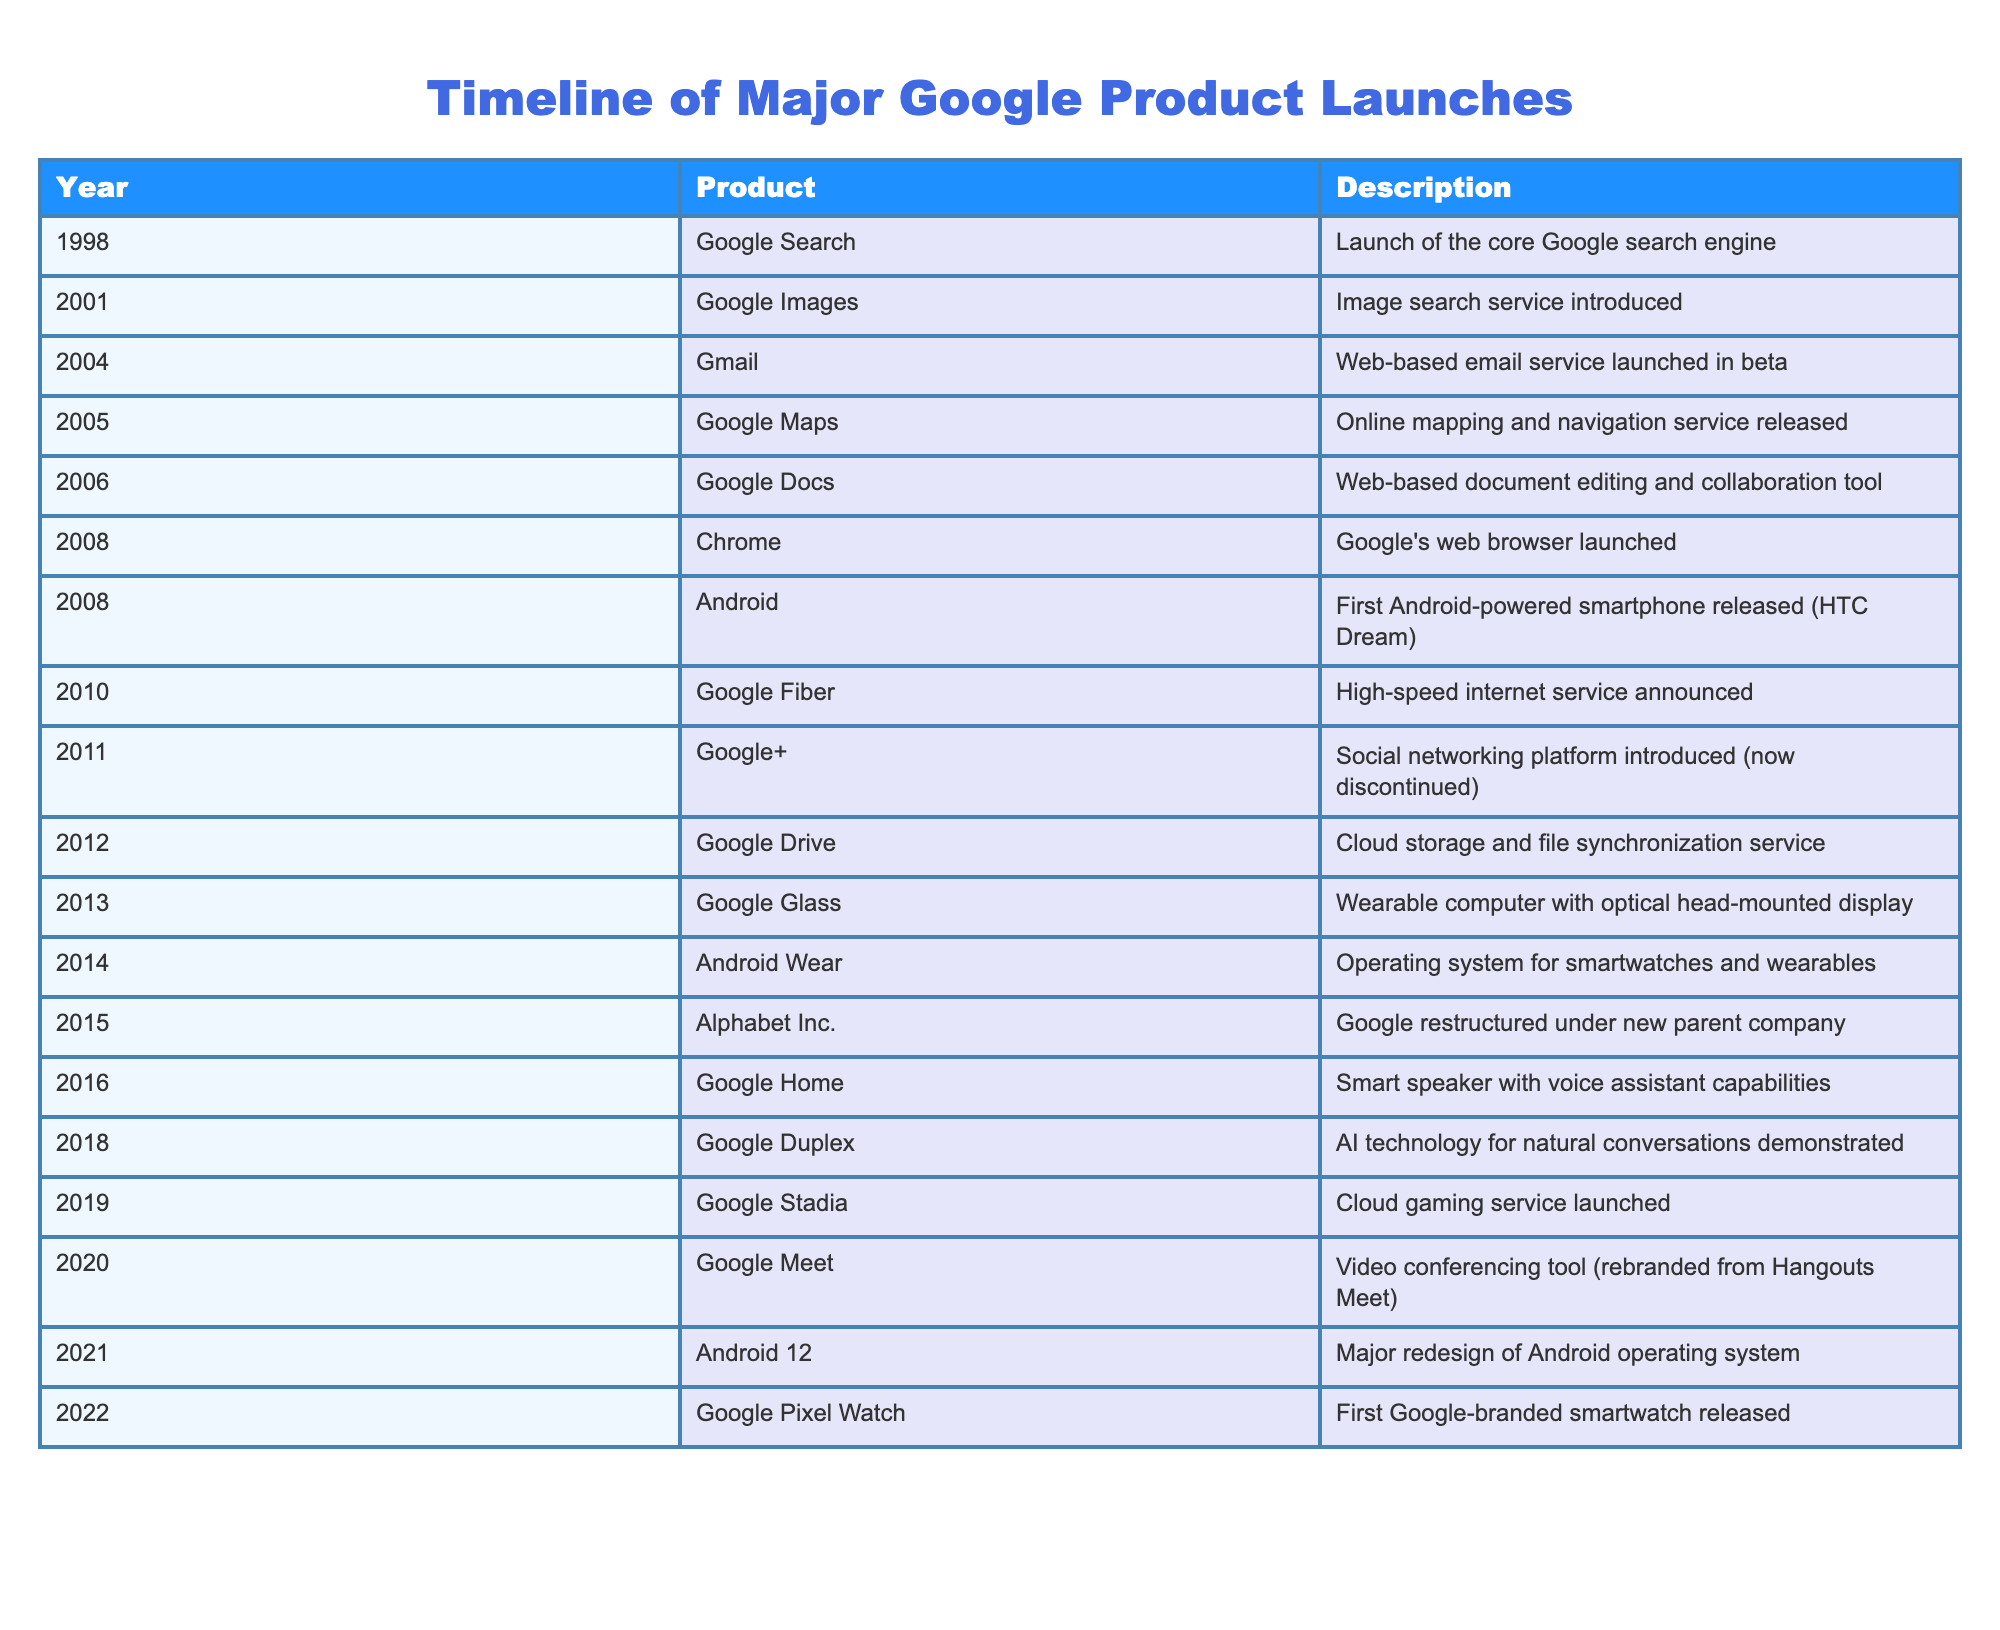What year was Google Search launched? The table lists Google Search under the year 1998.
Answer: 1998 How many products were launched between 2000 and 2010? The products launched in that range are Google Images (2001), Gmail (2004), Google Maps (2005), Google Docs (2006), and Google Chrome (2008). Counting these gives a total of 5 products.
Answer: 5 Was Google+ launched after Google Drive? Google+ was introduced in 2011 and Google Drive was launched in 2012. Since 2011 is before 2012, the statement is false.
Answer: No Which product was launched first, Android or Chrome? Android was first launched in 2008, while Chrome was also launched in 2008. However, since Android is listed first in the table, it precedes Chrome in order of launch.
Answer: Android What is the total number of products introduced from 2010 onwards? The products introduced from 2010 onwards are Google Fiber (2010), Google+ (2011), Google Drive (2012), Google Glass (2013), Android Wear (2014), Alphabet Inc. (2015), Google Home (2016), Google Duplex (2018), Google Stadia (2019), Google Meet (2020), Android 12 (2021), and Google Pixel Watch (2022). Counting these, we find there are 12 products.
Answer: 12 Which product was associated with an AI technology and in what year was it launched? The table shows that Google Duplex, which is AI technology for natural conversations, was introduced in 2018.
Answer: Google Duplex, 2018 Identify the years when both Google Maps and Google Drive were launched. Google Maps was launched in 2005 and Google Drive was launched in 2012. The two do not share the same year, so there are no years when both were launched.
Answer: None Was Alphabet Inc. launched as a new product or as a corporate restructuring? Alphabet Inc. was a restructuring under a new parent company for Google, as noted in the table. Therefore, it was not a new product launch.
Answer: No 